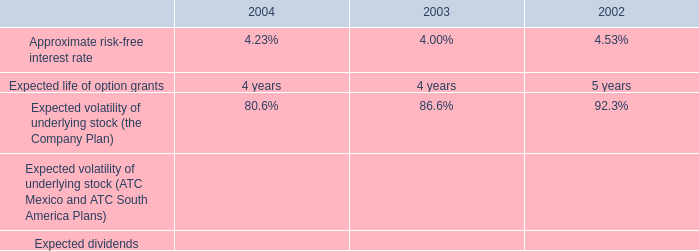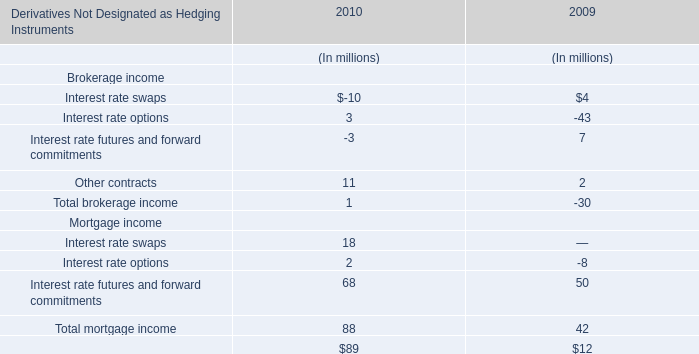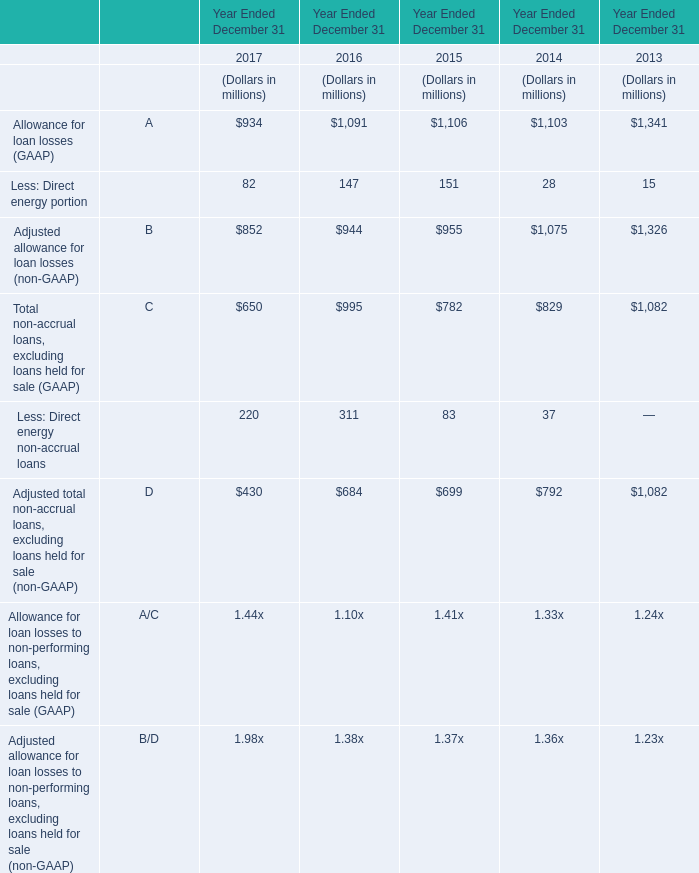what is the growth rate in weighted average fair values of the company 2019s options granted from 2002 to 2003? 
Computations: ((6.32 - 2.23) / 2.23)
Answer: 1.83408. 